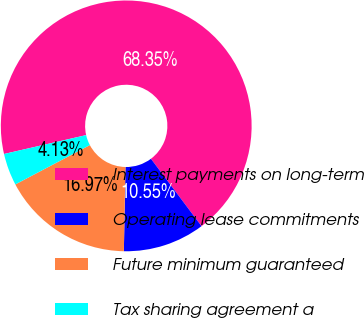<chart> <loc_0><loc_0><loc_500><loc_500><pie_chart><fcel>Interest payments on long-term<fcel>Operating lease commitments<fcel>Future minimum guaranteed<fcel>Tax sharing agreement a<nl><fcel>68.35%<fcel>10.55%<fcel>16.97%<fcel>4.13%<nl></chart> 